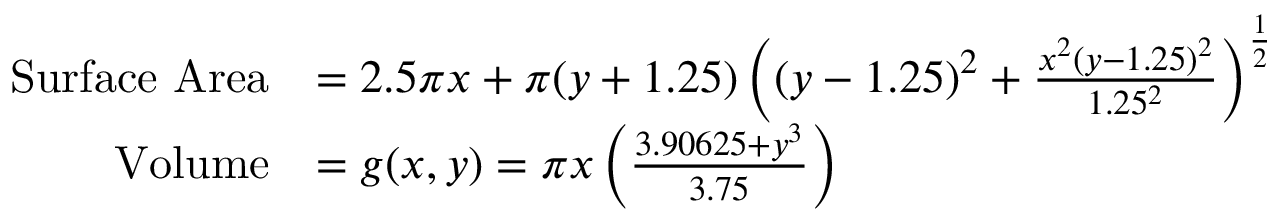Convert formula to latex. <formula><loc_0><loc_0><loc_500><loc_500>\begin{array} { r l } { S u r f a c e A r e a } & { = 2 . 5 \pi x + \pi ( y + 1 . 2 5 ) \left ( ( y - 1 . 2 5 ) ^ { 2 } + \frac { x ^ { 2 } \left ( y - 1 . 2 5 \right ) ^ { 2 } } { 1 . 2 5 ^ { 2 } } \right ) ^ { \frac { 1 } { 2 } } } \\ { V o l u m e } & { = g ( x , y ) = \pi x \left ( \frac { 3 . 9 0 6 2 5 + y ^ { 3 } } { 3 . 7 5 } \right ) } \end{array}</formula> 